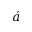<formula> <loc_0><loc_0><loc_500><loc_500>\acute { a }</formula> 